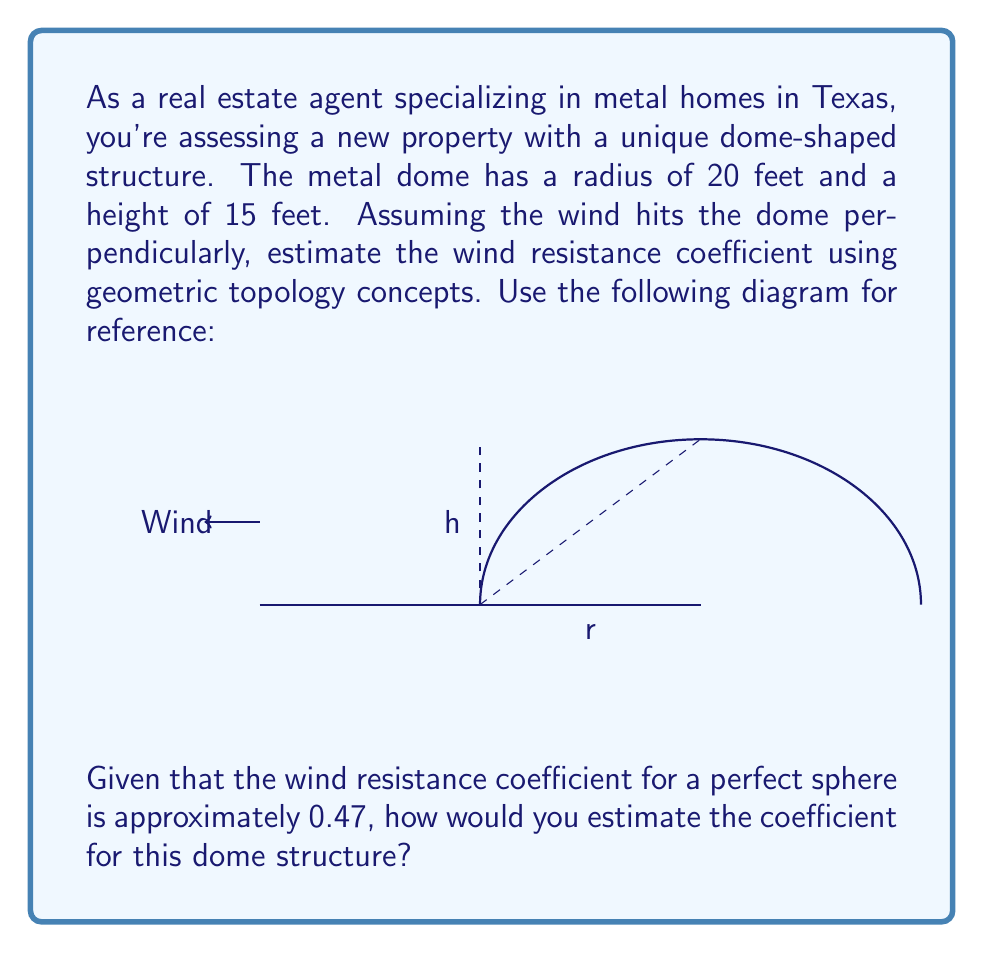Show me your answer to this math problem. To estimate the wind resistance coefficient of the dome-shaped metal home, we'll use concepts from geometric topology and fluid dynamics. Let's approach this step-by-step:

1) First, we need to understand that the wind resistance coefficient (often denoted as $C_d$) depends on the shape of the object. A perfect sphere has a $C_d$ of approximately 0.47.

2) Our dome is not a complete sphere, but rather a section of a sphere. We can use the ratio of the dome's surface area to that of a complete sphere to adjust the coefficient.

3) The surface area of a sphere is $4\pi r^2$, where $r$ is the radius.

4) For our dome, we need to calculate the surface area of a spherical cap. The formula for this is:

   $$A_{cap} = 2\pi r h$$

   where $h$ is the height of the cap.

5) Let's calculate:
   $$A_{cap} = 2\pi \cdot 20 \cdot 15 = 1884.96 \text{ sq ft}$$

6) The surface area of a complete sphere with radius 20 ft would be:
   $$A_{sphere} = 4\pi r^2 = 4\pi \cdot 20^2 = 5026.55 \text{ sq ft}$$

7) The ratio of the dome's surface area to a complete sphere is:
   $$\frac{A_{cap}}{A_{sphere}} = \frac{1884.96}{5026.55} \approx 0.3750$$

8) We can use this ratio to estimate the wind resistance coefficient for our dome:
   $$C_{d_{dome}} \approx C_{d_{sphere}} \cdot \frac{A_{cap}}{A_{sphere}}$$
   $$C_{d_{dome}} \approx 0.47 \cdot 0.3750 \approx 0.1763$$

9) However, we should consider that the flat bottom of the dome might increase turbulence slightly. As a conservative estimate, we might increase this value by about 10%:

   $$C_{d_{dome_{adjusted}}} \approx 0.1763 \cdot 1.1 \approx 0.1939$$

Therefore, we can estimate the wind resistance coefficient of the dome-shaped metal home to be approximately 0.19.
Answer: $C_d \approx 0.19$ 